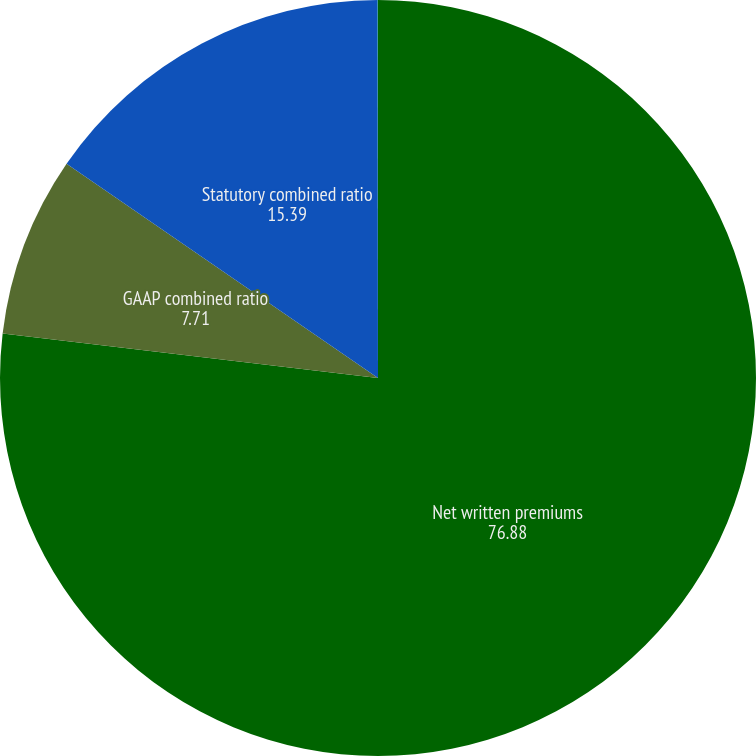Convert chart to OTSL. <chart><loc_0><loc_0><loc_500><loc_500><pie_chart><fcel>Net written premiums<fcel>GAAP combined ratio<fcel>Statutory combined ratio<fcel>Written premium to statutory<nl><fcel>76.88%<fcel>7.71%<fcel>15.39%<fcel>0.02%<nl></chart> 